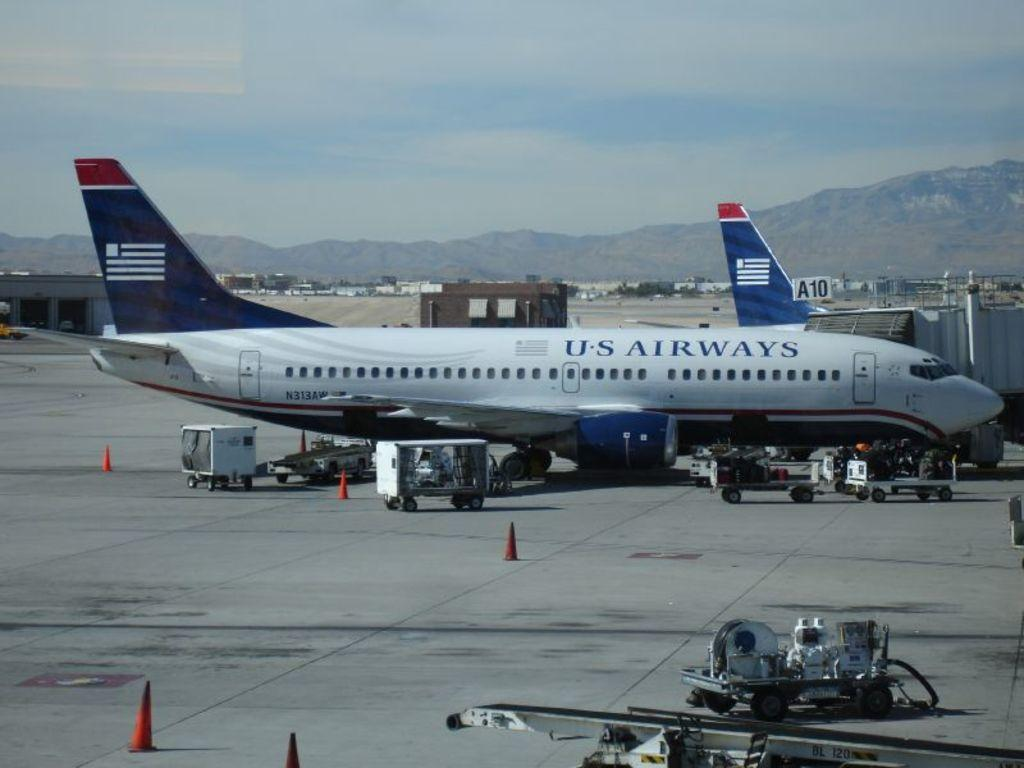<image>
Write a terse but informative summary of the picture. An U.S. Airways airplane on the tarmac with carts of luggage. 